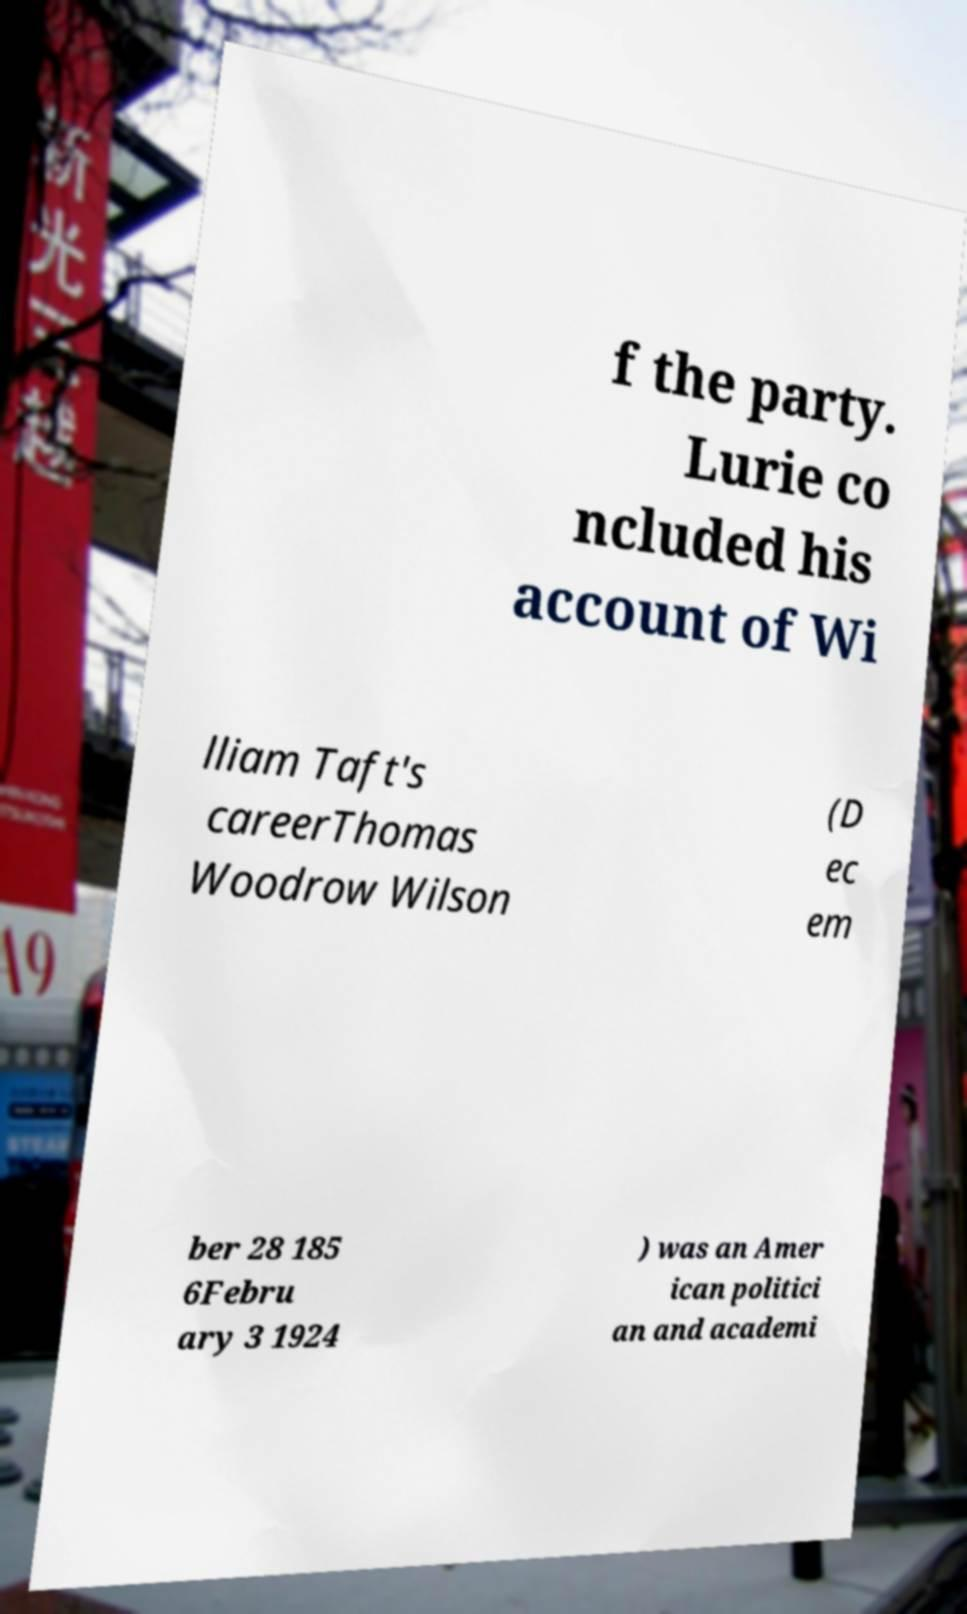Can you accurately transcribe the text from the provided image for me? f the party. Lurie co ncluded his account of Wi lliam Taft's careerThomas Woodrow Wilson (D ec em ber 28 185 6Febru ary 3 1924 ) was an Amer ican politici an and academi 